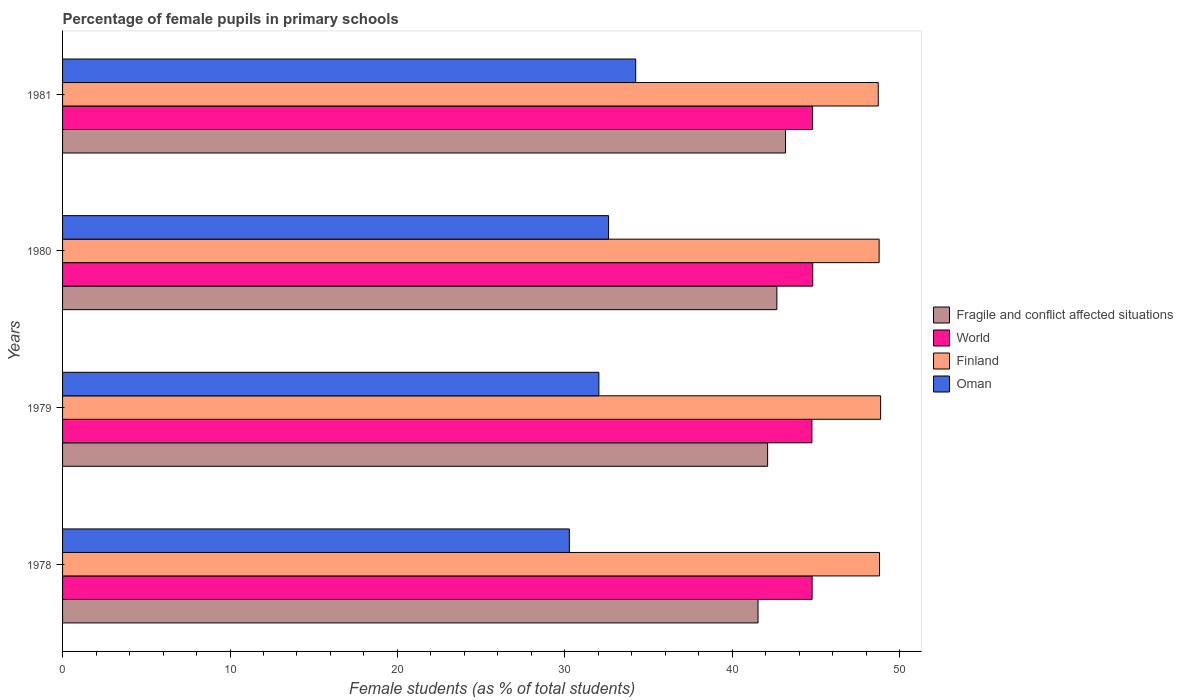Are the number of bars per tick equal to the number of legend labels?
Ensure brevity in your answer.  Yes. How many bars are there on the 1st tick from the bottom?
Provide a short and direct response. 4. What is the percentage of female pupils in primary schools in Finland in 1979?
Your answer should be compact. 48.86. Across all years, what is the maximum percentage of female pupils in primary schools in Oman?
Your answer should be very brief. 34.23. Across all years, what is the minimum percentage of female pupils in primary schools in Oman?
Provide a succinct answer. 30.27. In which year was the percentage of female pupils in primary schools in Finland maximum?
Offer a terse response. 1979. What is the total percentage of female pupils in primary schools in World in the graph?
Your response must be concise. 179.11. What is the difference between the percentage of female pupils in primary schools in Oman in 1978 and that in 1979?
Keep it short and to the point. -1.76. What is the difference between the percentage of female pupils in primary schools in Fragile and conflict affected situations in 1979 and the percentage of female pupils in primary schools in Finland in 1980?
Provide a short and direct response. -6.66. What is the average percentage of female pupils in primary schools in World per year?
Give a very brief answer. 44.78. In the year 1979, what is the difference between the percentage of female pupils in primary schools in Fragile and conflict affected situations and percentage of female pupils in primary schools in World?
Keep it short and to the point. -2.65. What is the ratio of the percentage of female pupils in primary schools in World in 1980 to that in 1981?
Keep it short and to the point. 1. Is the percentage of female pupils in primary schools in Oman in 1978 less than that in 1981?
Give a very brief answer. Yes. What is the difference between the highest and the second highest percentage of female pupils in primary schools in Finland?
Offer a terse response. 0.07. What is the difference between the highest and the lowest percentage of female pupils in primary schools in Oman?
Make the answer very short. 3.96. In how many years, is the percentage of female pupils in primary schools in Oman greater than the average percentage of female pupils in primary schools in Oman taken over all years?
Keep it short and to the point. 2. Is the sum of the percentage of female pupils in primary schools in Fragile and conflict affected situations in 1978 and 1981 greater than the maximum percentage of female pupils in primary schools in Oman across all years?
Your answer should be compact. Yes. Is it the case that in every year, the sum of the percentage of female pupils in primary schools in Finland and percentage of female pupils in primary schools in Fragile and conflict affected situations is greater than the sum of percentage of female pupils in primary schools in Oman and percentage of female pupils in primary schools in World?
Your answer should be very brief. Yes. What does the 4th bar from the top in 1980 represents?
Make the answer very short. Fragile and conflict affected situations. Is it the case that in every year, the sum of the percentage of female pupils in primary schools in World and percentage of female pupils in primary schools in Oman is greater than the percentage of female pupils in primary schools in Finland?
Ensure brevity in your answer.  Yes. What is the difference between two consecutive major ticks on the X-axis?
Your response must be concise. 10. Does the graph contain any zero values?
Offer a terse response. No. Does the graph contain grids?
Provide a short and direct response. No. Where does the legend appear in the graph?
Provide a short and direct response. Center right. How many legend labels are there?
Give a very brief answer. 4. How are the legend labels stacked?
Provide a short and direct response. Vertical. What is the title of the graph?
Your answer should be very brief. Percentage of female pupils in primary schools. What is the label or title of the X-axis?
Offer a terse response. Female students (as % of total students). What is the label or title of the Y-axis?
Your response must be concise. Years. What is the Female students (as % of total students) of Fragile and conflict affected situations in 1978?
Your answer should be compact. 41.53. What is the Female students (as % of total students) in World in 1978?
Provide a short and direct response. 44.76. What is the Female students (as % of total students) of Finland in 1978?
Your response must be concise. 48.79. What is the Female students (as % of total students) of Oman in 1978?
Your response must be concise. 30.27. What is the Female students (as % of total students) of Fragile and conflict affected situations in 1979?
Give a very brief answer. 42.11. What is the Female students (as % of total students) of World in 1979?
Your response must be concise. 44.75. What is the Female students (as % of total students) of Finland in 1979?
Your answer should be very brief. 48.86. What is the Female students (as % of total students) of Oman in 1979?
Make the answer very short. 32.03. What is the Female students (as % of total students) of Fragile and conflict affected situations in 1980?
Ensure brevity in your answer.  42.66. What is the Female students (as % of total students) of World in 1980?
Provide a short and direct response. 44.8. What is the Female students (as % of total students) of Finland in 1980?
Offer a terse response. 48.77. What is the Female students (as % of total students) of Oman in 1980?
Offer a very short reply. 32.61. What is the Female students (as % of total students) in Fragile and conflict affected situations in 1981?
Give a very brief answer. 43.18. What is the Female students (as % of total students) in World in 1981?
Ensure brevity in your answer.  44.79. What is the Female students (as % of total students) of Finland in 1981?
Your answer should be compact. 48.72. What is the Female students (as % of total students) of Oman in 1981?
Your answer should be compact. 34.23. Across all years, what is the maximum Female students (as % of total students) of Fragile and conflict affected situations?
Ensure brevity in your answer.  43.18. Across all years, what is the maximum Female students (as % of total students) in World?
Keep it short and to the point. 44.8. Across all years, what is the maximum Female students (as % of total students) in Finland?
Your answer should be very brief. 48.86. Across all years, what is the maximum Female students (as % of total students) in Oman?
Provide a succinct answer. 34.23. Across all years, what is the minimum Female students (as % of total students) of Fragile and conflict affected situations?
Keep it short and to the point. 41.53. Across all years, what is the minimum Female students (as % of total students) of World?
Make the answer very short. 44.75. Across all years, what is the minimum Female students (as % of total students) of Finland?
Make the answer very short. 48.72. Across all years, what is the minimum Female students (as % of total students) of Oman?
Provide a short and direct response. 30.27. What is the total Female students (as % of total students) in Fragile and conflict affected situations in the graph?
Your response must be concise. 169.48. What is the total Female students (as % of total students) of World in the graph?
Give a very brief answer. 179.11. What is the total Female students (as % of total students) in Finland in the graph?
Your response must be concise. 195.13. What is the total Female students (as % of total students) in Oman in the graph?
Your answer should be compact. 129.13. What is the difference between the Female students (as % of total students) in Fragile and conflict affected situations in 1978 and that in 1979?
Your answer should be compact. -0.57. What is the difference between the Female students (as % of total students) of World in 1978 and that in 1979?
Provide a short and direct response. 0.01. What is the difference between the Female students (as % of total students) in Finland in 1978 and that in 1979?
Keep it short and to the point. -0.07. What is the difference between the Female students (as % of total students) of Oman in 1978 and that in 1979?
Your response must be concise. -1.76. What is the difference between the Female students (as % of total students) in Fragile and conflict affected situations in 1978 and that in 1980?
Make the answer very short. -1.12. What is the difference between the Female students (as % of total students) in World in 1978 and that in 1980?
Your answer should be compact. -0.04. What is the difference between the Female students (as % of total students) in Finland in 1978 and that in 1980?
Make the answer very short. 0.02. What is the difference between the Female students (as % of total students) in Oman in 1978 and that in 1980?
Offer a terse response. -2.34. What is the difference between the Female students (as % of total students) in Fragile and conflict affected situations in 1978 and that in 1981?
Your response must be concise. -1.64. What is the difference between the Female students (as % of total students) in World in 1978 and that in 1981?
Your response must be concise. -0.03. What is the difference between the Female students (as % of total students) of Finland in 1978 and that in 1981?
Your answer should be compact. 0.07. What is the difference between the Female students (as % of total students) of Oman in 1978 and that in 1981?
Provide a short and direct response. -3.96. What is the difference between the Female students (as % of total students) in Fragile and conflict affected situations in 1979 and that in 1980?
Offer a very short reply. -0.55. What is the difference between the Female students (as % of total students) in World in 1979 and that in 1980?
Provide a succinct answer. -0.05. What is the difference between the Female students (as % of total students) in Finland in 1979 and that in 1980?
Offer a terse response. 0.09. What is the difference between the Female students (as % of total students) in Oman in 1979 and that in 1980?
Your answer should be very brief. -0.58. What is the difference between the Female students (as % of total students) in Fragile and conflict affected situations in 1979 and that in 1981?
Your response must be concise. -1.07. What is the difference between the Female students (as % of total students) of World in 1979 and that in 1981?
Offer a terse response. -0.04. What is the difference between the Female students (as % of total students) in Finland in 1979 and that in 1981?
Provide a short and direct response. 0.14. What is the difference between the Female students (as % of total students) of Oman in 1979 and that in 1981?
Offer a very short reply. -2.2. What is the difference between the Female students (as % of total students) in Fragile and conflict affected situations in 1980 and that in 1981?
Ensure brevity in your answer.  -0.52. What is the difference between the Female students (as % of total students) in World in 1980 and that in 1981?
Provide a succinct answer. 0.01. What is the difference between the Female students (as % of total students) of Finland in 1980 and that in 1981?
Your answer should be compact. 0.05. What is the difference between the Female students (as % of total students) of Oman in 1980 and that in 1981?
Provide a succinct answer. -1.62. What is the difference between the Female students (as % of total students) in Fragile and conflict affected situations in 1978 and the Female students (as % of total students) in World in 1979?
Ensure brevity in your answer.  -3.22. What is the difference between the Female students (as % of total students) of Fragile and conflict affected situations in 1978 and the Female students (as % of total students) of Finland in 1979?
Ensure brevity in your answer.  -7.32. What is the difference between the Female students (as % of total students) in Fragile and conflict affected situations in 1978 and the Female students (as % of total students) in Oman in 1979?
Give a very brief answer. 9.5. What is the difference between the Female students (as % of total students) in World in 1978 and the Female students (as % of total students) in Finland in 1979?
Your response must be concise. -4.09. What is the difference between the Female students (as % of total students) of World in 1978 and the Female students (as % of total students) of Oman in 1979?
Provide a succinct answer. 12.73. What is the difference between the Female students (as % of total students) of Finland in 1978 and the Female students (as % of total students) of Oman in 1979?
Keep it short and to the point. 16.76. What is the difference between the Female students (as % of total students) of Fragile and conflict affected situations in 1978 and the Female students (as % of total students) of World in 1980?
Provide a succinct answer. -3.27. What is the difference between the Female students (as % of total students) of Fragile and conflict affected situations in 1978 and the Female students (as % of total students) of Finland in 1980?
Provide a succinct answer. -7.23. What is the difference between the Female students (as % of total students) in Fragile and conflict affected situations in 1978 and the Female students (as % of total students) in Oman in 1980?
Your answer should be very brief. 8.93. What is the difference between the Female students (as % of total students) in World in 1978 and the Female students (as % of total students) in Finland in 1980?
Make the answer very short. -4. What is the difference between the Female students (as % of total students) of World in 1978 and the Female students (as % of total students) of Oman in 1980?
Keep it short and to the point. 12.16. What is the difference between the Female students (as % of total students) of Finland in 1978 and the Female students (as % of total students) of Oman in 1980?
Your answer should be compact. 16.18. What is the difference between the Female students (as % of total students) in Fragile and conflict affected situations in 1978 and the Female students (as % of total students) in World in 1981?
Provide a succinct answer. -3.26. What is the difference between the Female students (as % of total students) in Fragile and conflict affected situations in 1978 and the Female students (as % of total students) in Finland in 1981?
Offer a very short reply. -7.18. What is the difference between the Female students (as % of total students) of Fragile and conflict affected situations in 1978 and the Female students (as % of total students) of Oman in 1981?
Make the answer very short. 7.31. What is the difference between the Female students (as % of total students) of World in 1978 and the Female students (as % of total students) of Finland in 1981?
Provide a succinct answer. -3.95. What is the difference between the Female students (as % of total students) in World in 1978 and the Female students (as % of total students) in Oman in 1981?
Give a very brief answer. 10.54. What is the difference between the Female students (as % of total students) of Finland in 1978 and the Female students (as % of total students) of Oman in 1981?
Offer a terse response. 14.56. What is the difference between the Female students (as % of total students) of Fragile and conflict affected situations in 1979 and the Female students (as % of total students) of World in 1980?
Give a very brief answer. -2.69. What is the difference between the Female students (as % of total students) of Fragile and conflict affected situations in 1979 and the Female students (as % of total students) of Finland in 1980?
Offer a very short reply. -6.66. What is the difference between the Female students (as % of total students) in Fragile and conflict affected situations in 1979 and the Female students (as % of total students) in Oman in 1980?
Your answer should be compact. 9.5. What is the difference between the Female students (as % of total students) of World in 1979 and the Female students (as % of total students) of Finland in 1980?
Provide a succinct answer. -4.01. What is the difference between the Female students (as % of total students) in World in 1979 and the Female students (as % of total students) in Oman in 1980?
Provide a succinct answer. 12.15. What is the difference between the Female students (as % of total students) of Finland in 1979 and the Female students (as % of total students) of Oman in 1980?
Your answer should be very brief. 16.25. What is the difference between the Female students (as % of total students) in Fragile and conflict affected situations in 1979 and the Female students (as % of total students) in World in 1981?
Keep it short and to the point. -2.68. What is the difference between the Female students (as % of total students) of Fragile and conflict affected situations in 1979 and the Female students (as % of total students) of Finland in 1981?
Provide a short and direct response. -6.61. What is the difference between the Female students (as % of total students) of Fragile and conflict affected situations in 1979 and the Female students (as % of total students) of Oman in 1981?
Your response must be concise. 7.88. What is the difference between the Female students (as % of total students) of World in 1979 and the Female students (as % of total students) of Finland in 1981?
Your answer should be very brief. -3.96. What is the difference between the Female students (as % of total students) of World in 1979 and the Female students (as % of total students) of Oman in 1981?
Ensure brevity in your answer.  10.52. What is the difference between the Female students (as % of total students) in Finland in 1979 and the Female students (as % of total students) in Oman in 1981?
Give a very brief answer. 14.63. What is the difference between the Female students (as % of total students) of Fragile and conflict affected situations in 1980 and the Female students (as % of total students) of World in 1981?
Your answer should be compact. -2.13. What is the difference between the Female students (as % of total students) in Fragile and conflict affected situations in 1980 and the Female students (as % of total students) in Finland in 1981?
Ensure brevity in your answer.  -6.06. What is the difference between the Female students (as % of total students) in Fragile and conflict affected situations in 1980 and the Female students (as % of total students) in Oman in 1981?
Provide a short and direct response. 8.43. What is the difference between the Female students (as % of total students) of World in 1980 and the Female students (as % of total students) of Finland in 1981?
Your answer should be very brief. -3.91. What is the difference between the Female students (as % of total students) in World in 1980 and the Female students (as % of total students) in Oman in 1981?
Your response must be concise. 10.57. What is the difference between the Female students (as % of total students) in Finland in 1980 and the Female students (as % of total students) in Oman in 1981?
Make the answer very short. 14.54. What is the average Female students (as % of total students) of Fragile and conflict affected situations per year?
Give a very brief answer. 42.37. What is the average Female students (as % of total students) in World per year?
Your answer should be very brief. 44.78. What is the average Female students (as % of total students) in Finland per year?
Your answer should be very brief. 48.78. What is the average Female students (as % of total students) of Oman per year?
Your answer should be compact. 32.28. In the year 1978, what is the difference between the Female students (as % of total students) of Fragile and conflict affected situations and Female students (as % of total students) of World?
Offer a terse response. -3.23. In the year 1978, what is the difference between the Female students (as % of total students) in Fragile and conflict affected situations and Female students (as % of total students) in Finland?
Your response must be concise. -7.25. In the year 1978, what is the difference between the Female students (as % of total students) in Fragile and conflict affected situations and Female students (as % of total students) in Oman?
Provide a short and direct response. 11.27. In the year 1978, what is the difference between the Female students (as % of total students) in World and Female students (as % of total students) in Finland?
Give a very brief answer. -4.02. In the year 1978, what is the difference between the Female students (as % of total students) of World and Female students (as % of total students) of Oman?
Your answer should be very brief. 14.5. In the year 1978, what is the difference between the Female students (as % of total students) of Finland and Female students (as % of total students) of Oman?
Ensure brevity in your answer.  18.52. In the year 1979, what is the difference between the Female students (as % of total students) of Fragile and conflict affected situations and Female students (as % of total students) of World?
Your answer should be very brief. -2.65. In the year 1979, what is the difference between the Female students (as % of total students) of Fragile and conflict affected situations and Female students (as % of total students) of Finland?
Keep it short and to the point. -6.75. In the year 1979, what is the difference between the Female students (as % of total students) of Fragile and conflict affected situations and Female students (as % of total students) of Oman?
Offer a very short reply. 10.08. In the year 1979, what is the difference between the Female students (as % of total students) in World and Female students (as % of total students) in Finland?
Give a very brief answer. -4.1. In the year 1979, what is the difference between the Female students (as % of total students) of World and Female students (as % of total students) of Oman?
Make the answer very short. 12.72. In the year 1979, what is the difference between the Female students (as % of total students) of Finland and Female students (as % of total students) of Oman?
Your answer should be compact. 16.83. In the year 1980, what is the difference between the Female students (as % of total students) in Fragile and conflict affected situations and Female students (as % of total students) in World?
Provide a succinct answer. -2.14. In the year 1980, what is the difference between the Female students (as % of total students) of Fragile and conflict affected situations and Female students (as % of total students) of Finland?
Your answer should be compact. -6.11. In the year 1980, what is the difference between the Female students (as % of total students) in Fragile and conflict affected situations and Female students (as % of total students) in Oman?
Offer a terse response. 10.05. In the year 1980, what is the difference between the Female students (as % of total students) of World and Female students (as % of total students) of Finland?
Keep it short and to the point. -3.97. In the year 1980, what is the difference between the Female students (as % of total students) in World and Female students (as % of total students) in Oman?
Provide a succinct answer. 12.19. In the year 1980, what is the difference between the Female students (as % of total students) in Finland and Female students (as % of total students) in Oman?
Keep it short and to the point. 16.16. In the year 1981, what is the difference between the Female students (as % of total students) in Fragile and conflict affected situations and Female students (as % of total students) in World?
Offer a terse response. -1.62. In the year 1981, what is the difference between the Female students (as % of total students) in Fragile and conflict affected situations and Female students (as % of total students) in Finland?
Your response must be concise. -5.54. In the year 1981, what is the difference between the Female students (as % of total students) of Fragile and conflict affected situations and Female students (as % of total students) of Oman?
Keep it short and to the point. 8.95. In the year 1981, what is the difference between the Female students (as % of total students) in World and Female students (as % of total students) in Finland?
Offer a terse response. -3.92. In the year 1981, what is the difference between the Female students (as % of total students) of World and Female students (as % of total students) of Oman?
Provide a short and direct response. 10.56. In the year 1981, what is the difference between the Female students (as % of total students) of Finland and Female students (as % of total students) of Oman?
Provide a short and direct response. 14.49. What is the ratio of the Female students (as % of total students) in Fragile and conflict affected situations in 1978 to that in 1979?
Ensure brevity in your answer.  0.99. What is the ratio of the Female students (as % of total students) in World in 1978 to that in 1979?
Offer a very short reply. 1. What is the ratio of the Female students (as % of total students) of Finland in 1978 to that in 1979?
Keep it short and to the point. 1. What is the ratio of the Female students (as % of total students) in Oman in 1978 to that in 1979?
Keep it short and to the point. 0.94. What is the ratio of the Female students (as % of total students) in Fragile and conflict affected situations in 1978 to that in 1980?
Offer a terse response. 0.97. What is the ratio of the Female students (as % of total students) in Finland in 1978 to that in 1980?
Your answer should be very brief. 1. What is the ratio of the Female students (as % of total students) in Oman in 1978 to that in 1980?
Ensure brevity in your answer.  0.93. What is the ratio of the Female students (as % of total students) in Finland in 1978 to that in 1981?
Provide a succinct answer. 1. What is the ratio of the Female students (as % of total students) in Oman in 1978 to that in 1981?
Your response must be concise. 0.88. What is the ratio of the Female students (as % of total students) of Fragile and conflict affected situations in 1979 to that in 1980?
Provide a succinct answer. 0.99. What is the ratio of the Female students (as % of total students) in Finland in 1979 to that in 1980?
Offer a terse response. 1. What is the ratio of the Female students (as % of total students) in Oman in 1979 to that in 1980?
Offer a very short reply. 0.98. What is the ratio of the Female students (as % of total students) in Fragile and conflict affected situations in 1979 to that in 1981?
Provide a short and direct response. 0.98. What is the ratio of the Female students (as % of total students) of Finland in 1979 to that in 1981?
Provide a succinct answer. 1. What is the ratio of the Female students (as % of total students) in Oman in 1979 to that in 1981?
Offer a very short reply. 0.94. What is the ratio of the Female students (as % of total students) of Finland in 1980 to that in 1981?
Ensure brevity in your answer.  1. What is the ratio of the Female students (as % of total students) of Oman in 1980 to that in 1981?
Make the answer very short. 0.95. What is the difference between the highest and the second highest Female students (as % of total students) of Fragile and conflict affected situations?
Make the answer very short. 0.52. What is the difference between the highest and the second highest Female students (as % of total students) in World?
Your answer should be compact. 0.01. What is the difference between the highest and the second highest Female students (as % of total students) of Finland?
Offer a very short reply. 0.07. What is the difference between the highest and the second highest Female students (as % of total students) in Oman?
Offer a very short reply. 1.62. What is the difference between the highest and the lowest Female students (as % of total students) in Fragile and conflict affected situations?
Give a very brief answer. 1.64. What is the difference between the highest and the lowest Female students (as % of total students) of World?
Give a very brief answer. 0.05. What is the difference between the highest and the lowest Female students (as % of total students) in Finland?
Your response must be concise. 0.14. What is the difference between the highest and the lowest Female students (as % of total students) of Oman?
Keep it short and to the point. 3.96. 